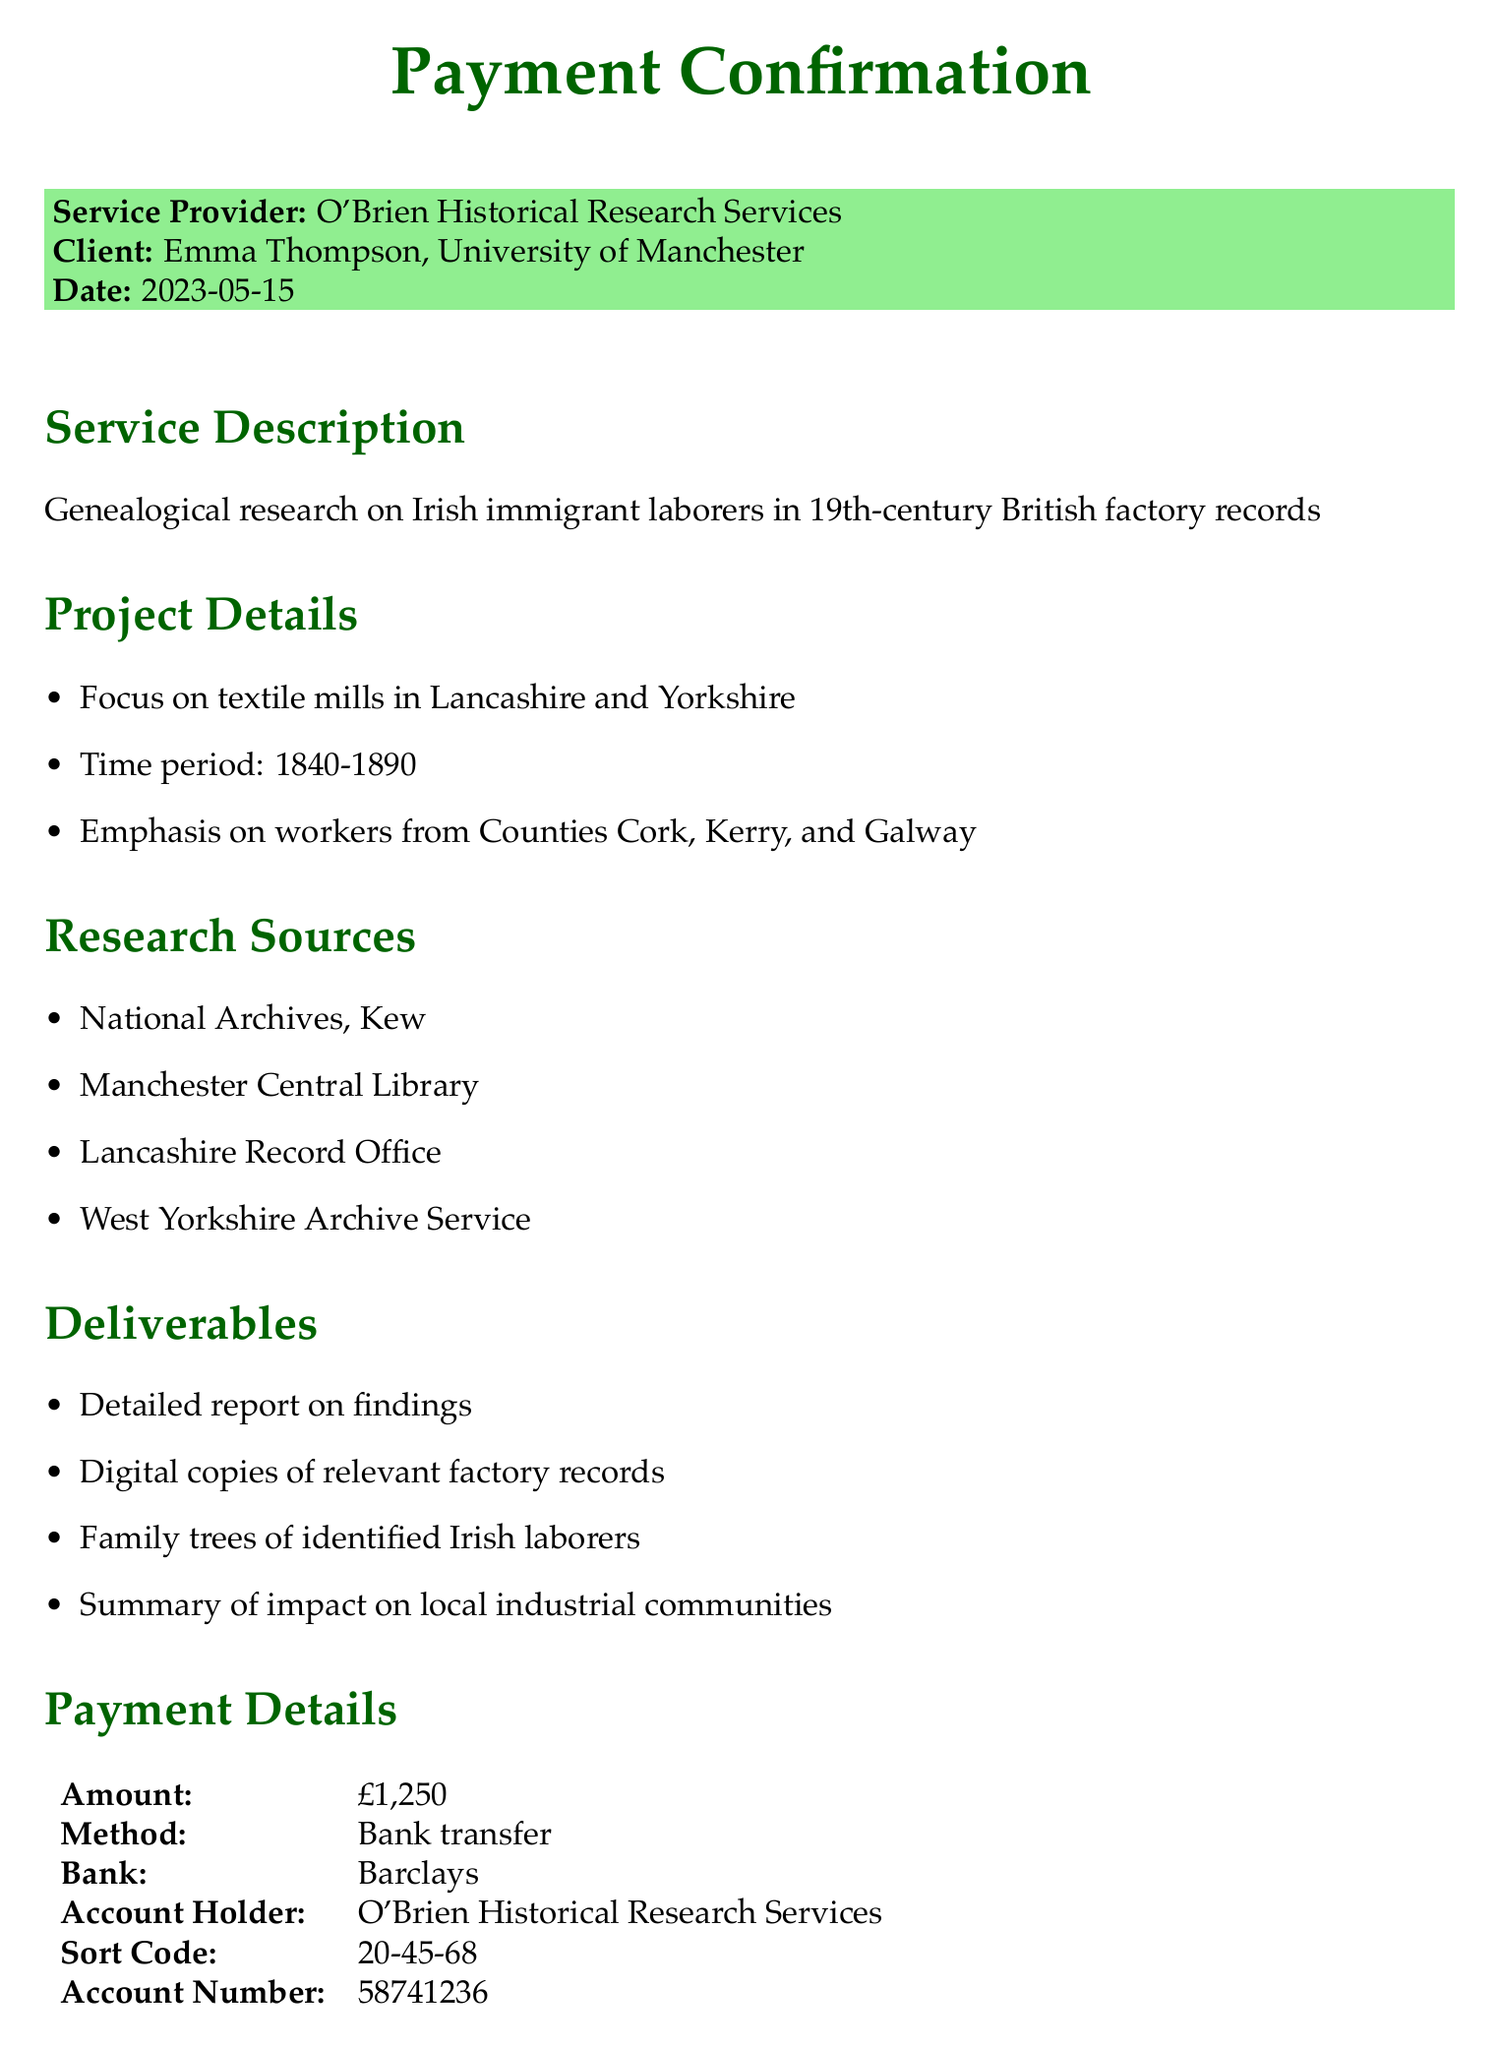What is the date of the payment confirmation? The date of the payment confirmation is explicitly mentioned in the document.
Answer: 2023-05-15 Who is the service provider? The name of the service provider is stated at the beginning of the document.
Answer: O'Brien Historical Research Services What is the total payment amount? The total payment amount is noted in the payment details section of the document.
Answer: £1,250 What is the duration of the project? The duration of the project is listed under the project timeline section.
Answer: 8 weeks Which counties are emphasized in the research? The counties emphasized in the research details are mentioned in the project details section.
Answer: Cork, Kerry, and Galway Who is the genealogist and what is her qualification? The document specifies the name of the genealogist and her qualifications in the genealogist information section.
Answer: Dr. Siobhan O'Brien, PhD in Irish Diaspora Studies What is the payment method? The payment method is stated in the payment details section.
Answer: Bank transfer What additional notes are provided in the document? The additional notes specify how the research findings will be used, found at the end of the document.
Answer: Research findings to be used in dissertation on Irish emigration's impact on British industrial history 